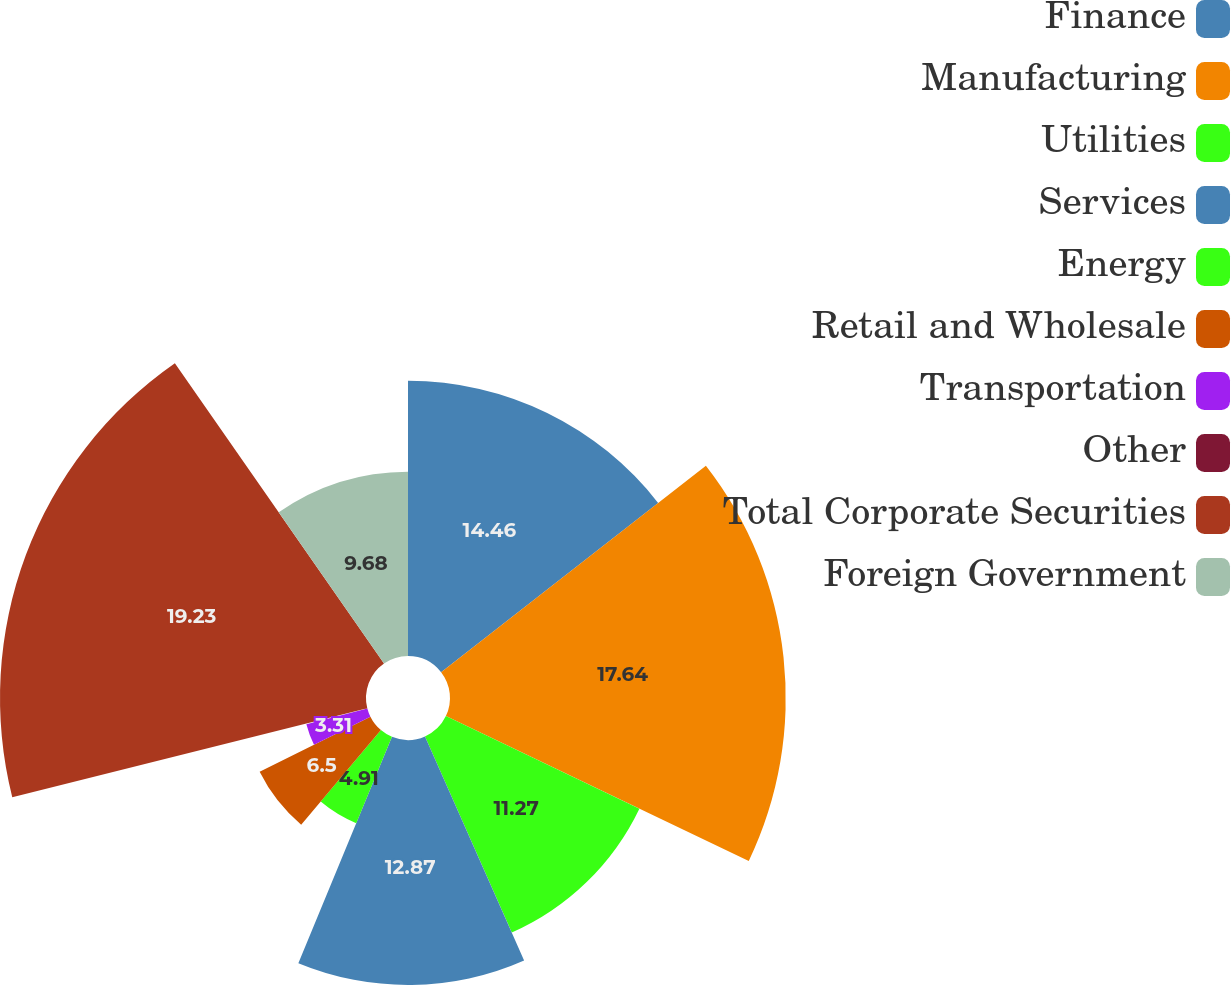Convert chart. <chart><loc_0><loc_0><loc_500><loc_500><pie_chart><fcel>Finance<fcel>Manufacturing<fcel>Utilities<fcel>Services<fcel>Energy<fcel>Retail and Wholesale<fcel>Transportation<fcel>Other<fcel>Total Corporate Securities<fcel>Foreign Government<nl><fcel>14.46%<fcel>17.64%<fcel>11.27%<fcel>12.87%<fcel>4.91%<fcel>6.5%<fcel>3.31%<fcel>0.13%<fcel>19.23%<fcel>9.68%<nl></chart> 